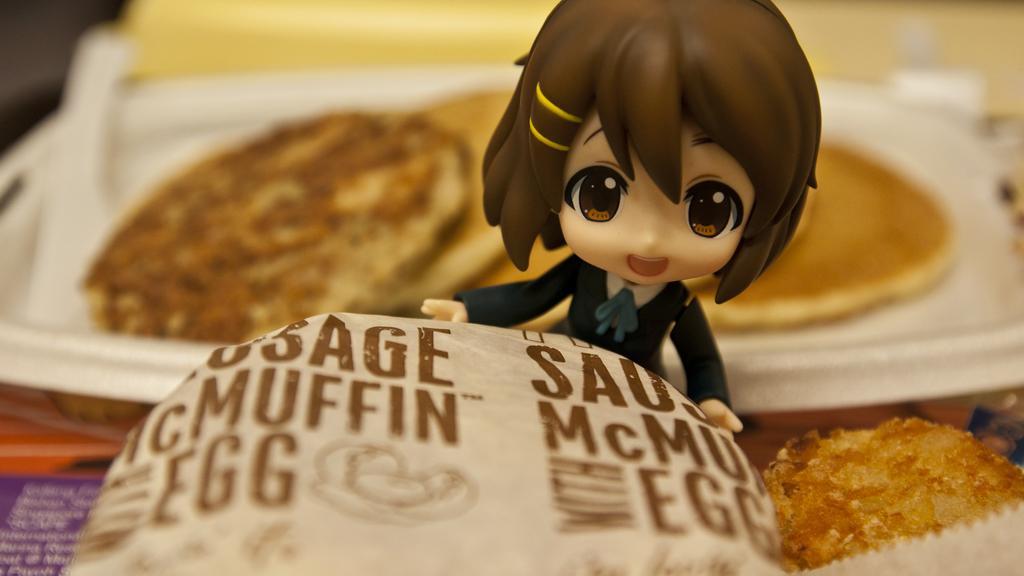Could you give a brief overview of what you see in this image? In the foreground of this image, there is a muffin and a paper with some text. In the middle, there is a toy. In the background, there is some food on a white tray and also an object on the left. 